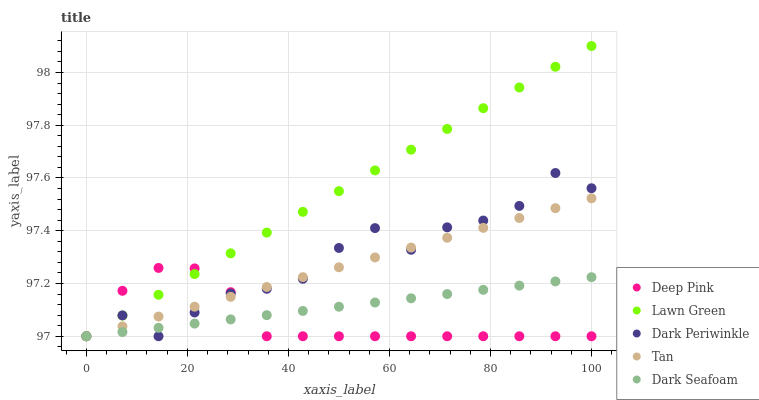Does Deep Pink have the minimum area under the curve?
Answer yes or no. Yes. Does Lawn Green have the maximum area under the curve?
Answer yes or no. Yes. Does Tan have the minimum area under the curve?
Answer yes or no. No. Does Tan have the maximum area under the curve?
Answer yes or no. No. Is Lawn Green the smoothest?
Answer yes or no. Yes. Is Dark Periwinkle the roughest?
Answer yes or no. Yes. Is Tan the smoothest?
Answer yes or no. No. Is Tan the roughest?
Answer yes or no. No. Does Lawn Green have the lowest value?
Answer yes or no. Yes. Does Lawn Green have the highest value?
Answer yes or no. Yes. Does Tan have the highest value?
Answer yes or no. No. Does Dark Periwinkle intersect Deep Pink?
Answer yes or no. Yes. Is Dark Periwinkle less than Deep Pink?
Answer yes or no. No. Is Dark Periwinkle greater than Deep Pink?
Answer yes or no. No. 